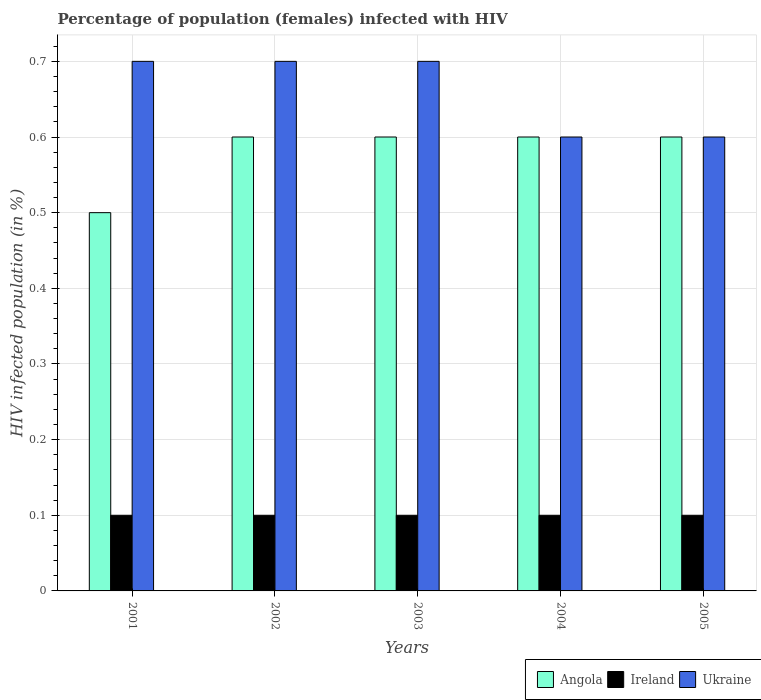How many bars are there on the 1st tick from the right?
Your response must be concise. 3. In how many cases, is the number of bars for a given year not equal to the number of legend labels?
Make the answer very short. 0. Across all years, what is the maximum percentage of HIV infected female population in Ukraine?
Keep it short and to the point. 0.7. Across all years, what is the minimum percentage of HIV infected female population in Angola?
Ensure brevity in your answer.  0.5. What is the total percentage of HIV infected female population in Angola in the graph?
Give a very brief answer. 2.9. What is the difference between the percentage of HIV infected female population in Ireland in 2002 and that in 2005?
Keep it short and to the point. 0. What is the difference between the percentage of HIV infected female population in Angola in 2001 and the percentage of HIV infected female population in Ireland in 2002?
Keep it short and to the point. 0.4. What is the average percentage of HIV infected female population in Angola per year?
Ensure brevity in your answer.  0.58. In the year 2004, what is the difference between the percentage of HIV infected female population in Angola and percentage of HIV infected female population in Ukraine?
Provide a short and direct response. 0. In how many years, is the percentage of HIV infected female population in Ireland greater than 0.1 %?
Offer a very short reply. 0. What is the difference between the highest and the second highest percentage of HIV infected female population in Ukraine?
Provide a succinct answer. 0. What is the difference between the highest and the lowest percentage of HIV infected female population in Angola?
Ensure brevity in your answer.  0.1. In how many years, is the percentage of HIV infected female population in Ireland greater than the average percentage of HIV infected female population in Ireland taken over all years?
Give a very brief answer. 0. What does the 2nd bar from the left in 2004 represents?
Your answer should be very brief. Ireland. What does the 1st bar from the right in 2003 represents?
Your response must be concise. Ukraine. Is it the case that in every year, the sum of the percentage of HIV infected female population in Ireland and percentage of HIV infected female population in Angola is greater than the percentage of HIV infected female population in Ukraine?
Your response must be concise. No. How many bars are there?
Give a very brief answer. 15. Are all the bars in the graph horizontal?
Your answer should be very brief. No. How many years are there in the graph?
Your response must be concise. 5. What is the difference between two consecutive major ticks on the Y-axis?
Keep it short and to the point. 0.1. Does the graph contain any zero values?
Your answer should be compact. No. Where does the legend appear in the graph?
Your response must be concise. Bottom right. How many legend labels are there?
Your answer should be very brief. 3. How are the legend labels stacked?
Your response must be concise. Horizontal. What is the title of the graph?
Your response must be concise. Percentage of population (females) infected with HIV. Does "Singapore" appear as one of the legend labels in the graph?
Provide a short and direct response. No. What is the label or title of the X-axis?
Keep it short and to the point. Years. What is the label or title of the Y-axis?
Provide a short and direct response. HIV infected population (in %). What is the HIV infected population (in %) of Angola in 2001?
Offer a terse response. 0.5. What is the HIV infected population (in %) of Ireland in 2001?
Offer a terse response. 0.1. What is the HIV infected population (in %) in Ukraine in 2001?
Keep it short and to the point. 0.7. What is the HIV infected population (in %) in Angola in 2002?
Your answer should be very brief. 0.6. What is the HIV infected population (in %) in Ireland in 2002?
Your response must be concise. 0.1. What is the HIV infected population (in %) of Ukraine in 2002?
Your answer should be compact. 0.7. What is the HIV infected population (in %) of Angola in 2003?
Give a very brief answer. 0.6. What is the HIV infected population (in %) of Ukraine in 2003?
Your answer should be very brief. 0.7. What is the HIV infected population (in %) in Angola in 2004?
Give a very brief answer. 0.6. What is the HIV infected population (in %) of Ireland in 2005?
Your answer should be very brief. 0.1. What is the HIV infected population (in %) of Ukraine in 2005?
Make the answer very short. 0.6. Across all years, what is the minimum HIV infected population (in %) in Angola?
Offer a very short reply. 0.5. What is the total HIV infected population (in %) of Ireland in the graph?
Give a very brief answer. 0.5. What is the difference between the HIV infected population (in %) in Angola in 2001 and that in 2002?
Give a very brief answer. -0.1. What is the difference between the HIV infected population (in %) in Ukraine in 2001 and that in 2003?
Provide a succinct answer. 0. What is the difference between the HIV infected population (in %) of Angola in 2001 and that in 2004?
Your answer should be compact. -0.1. What is the difference between the HIV infected population (in %) of Angola in 2001 and that in 2005?
Make the answer very short. -0.1. What is the difference between the HIV infected population (in %) in Angola in 2002 and that in 2003?
Offer a very short reply. 0. What is the difference between the HIV infected population (in %) in Ukraine in 2002 and that in 2003?
Your answer should be compact. 0. What is the difference between the HIV infected population (in %) of Angola in 2002 and that in 2004?
Give a very brief answer. 0. What is the difference between the HIV infected population (in %) in Ukraine in 2002 and that in 2004?
Provide a succinct answer. 0.1. What is the difference between the HIV infected population (in %) in Angola in 2002 and that in 2005?
Give a very brief answer. 0. What is the difference between the HIV infected population (in %) in Ireland in 2002 and that in 2005?
Keep it short and to the point. 0. What is the difference between the HIV infected population (in %) of Ukraine in 2002 and that in 2005?
Your answer should be compact. 0.1. What is the difference between the HIV infected population (in %) of Ireland in 2003 and that in 2004?
Your response must be concise. 0. What is the difference between the HIV infected population (in %) of Angola in 2003 and that in 2005?
Offer a terse response. 0. What is the difference between the HIV infected population (in %) of Angola in 2004 and that in 2005?
Make the answer very short. 0. What is the difference between the HIV infected population (in %) of Ireland in 2004 and that in 2005?
Your answer should be very brief. 0. What is the difference between the HIV infected population (in %) of Angola in 2001 and the HIV infected population (in %) of Ireland in 2004?
Your answer should be very brief. 0.4. What is the difference between the HIV infected population (in %) of Angola in 2001 and the HIV infected population (in %) of Ukraine in 2004?
Provide a succinct answer. -0.1. What is the difference between the HIV infected population (in %) in Angola in 2001 and the HIV infected population (in %) in Ukraine in 2005?
Give a very brief answer. -0.1. What is the difference between the HIV infected population (in %) of Angola in 2002 and the HIV infected population (in %) of Ukraine in 2003?
Your answer should be compact. -0.1. What is the difference between the HIV infected population (in %) in Angola in 2002 and the HIV infected population (in %) in Ireland in 2005?
Provide a short and direct response. 0.5. What is the difference between the HIV infected population (in %) of Angola in 2003 and the HIV infected population (in %) of Ireland in 2004?
Provide a short and direct response. 0.5. What is the difference between the HIV infected population (in %) in Angola in 2003 and the HIV infected population (in %) in Ukraine in 2004?
Provide a succinct answer. 0. What is the difference between the HIV infected population (in %) of Angola in 2003 and the HIV infected population (in %) of Ireland in 2005?
Ensure brevity in your answer.  0.5. What is the difference between the HIV infected population (in %) of Ireland in 2003 and the HIV infected population (in %) of Ukraine in 2005?
Provide a short and direct response. -0.5. What is the average HIV infected population (in %) in Angola per year?
Offer a terse response. 0.58. What is the average HIV infected population (in %) in Ukraine per year?
Offer a very short reply. 0.66. In the year 2001, what is the difference between the HIV infected population (in %) in Angola and HIV infected population (in %) in Ireland?
Offer a terse response. 0.4. In the year 2001, what is the difference between the HIV infected population (in %) in Angola and HIV infected population (in %) in Ukraine?
Offer a terse response. -0.2. In the year 2002, what is the difference between the HIV infected population (in %) of Angola and HIV infected population (in %) of Ireland?
Your answer should be compact. 0.5. In the year 2002, what is the difference between the HIV infected population (in %) in Angola and HIV infected population (in %) in Ukraine?
Your answer should be compact. -0.1. In the year 2002, what is the difference between the HIV infected population (in %) of Ireland and HIV infected population (in %) of Ukraine?
Your response must be concise. -0.6. In the year 2003, what is the difference between the HIV infected population (in %) of Angola and HIV infected population (in %) of Ireland?
Provide a short and direct response. 0.5. In the year 2003, what is the difference between the HIV infected population (in %) in Ireland and HIV infected population (in %) in Ukraine?
Your response must be concise. -0.6. In the year 2004, what is the difference between the HIV infected population (in %) in Angola and HIV infected population (in %) in Ireland?
Make the answer very short. 0.5. In the year 2004, what is the difference between the HIV infected population (in %) of Angola and HIV infected population (in %) of Ukraine?
Offer a very short reply. 0. In the year 2004, what is the difference between the HIV infected population (in %) in Ireland and HIV infected population (in %) in Ukraine?
Offer a terse response. -0.5. In the year 2005, what is the difference between the HIV infected population (in %) in Angola and HIV infected population (in %) in Ukraine?
Make the answer very short. 0. In the year 2005, what is the difference between the HIV infected population (in %) in Ireland and HIV infected population (in %) in Ukraine?
Offer a terse response. -0.5. What is the ratio of the HIV infected population (in %) in Angola in 2001 to that in 2002?
Ensure brevity in your answer.  0.83. What is the ratio of the HIV infected population (in %) in Ireland in 2001 to that in 2002?
Provide a short and direct response. 1. What is the ratio of the HIV infected population (in %) in Ukraine in 2001 to that in 2002?
Provide a short and direct response. 1. What is the ratio of the HIV infected population (in %) of Ireland in 2001 to that in 2003?
Your response must be concise. 1. What is the ratio of the HIV infected population (in %) of Angola in 2001 to that in 2004?
Make the answer very short. 0.83. What is the ratio of the HIV infected population (in %) in Ireland in 2001 to that in 2004?
Offer a very short reply. 1. What is the ratio of the HIV infected population (in %) in Angola in 2001 to that in 2005?
Your response must be concise. 0.83. What is the ratio of the HIV infected population (in %) of Ukraine in 2001 to that in 2005?
Your response must be concise. 1.17. What is the ratio of the HIV infected population (in %) in Ireland in 2002 to that in 2003?
Keep it short and to the point. 1. What is the ratio of the HIV infected population (in %) of Ukraine in 2002 to that in 2003?
Offer a terse response. 1. What is the ratio of the HIV infected population (in %) of Angola in 2002 to that in 2004?
Keep it short and to the point. 1. What is the ratio of the HIV infected population (in %) in Ireland in 2002 to that in 2005?
Offer a terse response. 1. What is the ratio of the HIV infected population (in %) in Angola in 2003 to that in 2004?
Keep it short and to the point. 1. What is the ratio of the HIV infected population (in %) in Ireland in 2003 to that in 2005?
Your answer should be compact. 1. What is the ratio of the HIV infected population (in %) of Ukraine in 2003 to that in 2005?
Provide a short and direct response. 1.17. What is the ratio of the HIV infected population (in %) in Angola in 2004 to that in 2005?
Give a very brief answer. 1. What is the ratio of the HIV infected population (in %) of Ireland in 2004 to that in 2005?
Your answer should be compact. 1. What is the ratio of the HIV infected population (in %) in Ukraine in 2004 to that in 2005?
Keep it short and to the point. 1. What is the difference between the highest and the second highest HIV infected population (in %) of Ukraine?
Your answer should be compact. 0. What is the difference between the highest and the lowest HIV infected population (in %) of Angola?
Your response must be concise. 0.1. What is the difference between the highest and the lowest HIV infected population (in %) of Ireland?
Ensure brevity in your answer.  0. 